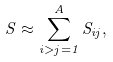Convert formula to latex. <formula><loc_0><loc_0><loc_500><loc_500>S \approx \sum _ { i > j = 1 } ^ { A } S _ { i j } ,</formula> 